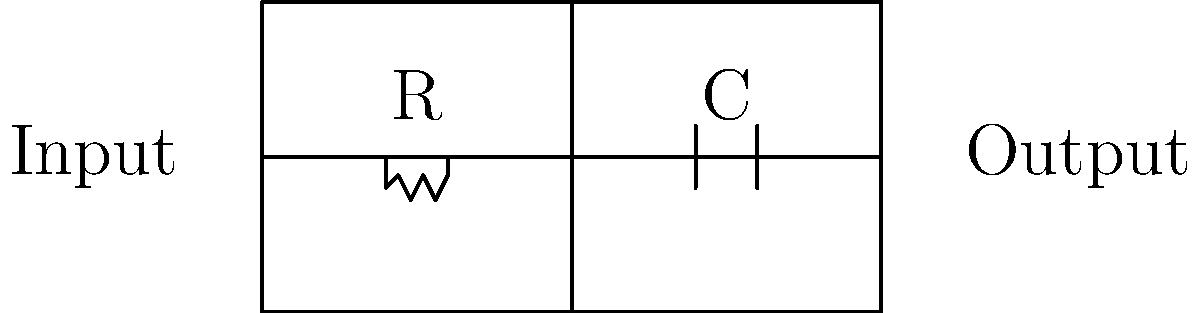In the context of early electronic music synthesizers, particularly those influenced by the Frankfurt School's critique of mass culture, analyze the circuit diagram provided. How might this simple RC (Resistor-Capacitor) filter contribute to the transformation of sound, and what philosophical implications could this have in relation to Adorno's concept of the "culture industry"? To answer this question, we need to consider both the technical aspects of the circuit and its potential philosophical implications:

1. Circuit Analysis:
   - The diagram shows a basic RC low-pass filter.
   - The resistor (R) and capacitor (C) are connected in series.
   - The output is taken across the capacitor.

2. Function in Sound Processing:
   - This filter attenuates high frequencies while allowing low frequencies to pass through.
   - The cutoff frequency is determined by the formula: $f_c = \frac{1}{2\pi RC}$

3. Effect on Sound:
   - It smooths out rapid changes in the input signal.
   - This can result in a "warmer" or "mellower" sound by reducing harsh overtones.

4. Relation to Early Synthesizers:
   - Early synthesizers often used simple analog circuits like this to shape sound.
   - The ability to manipulate sound electronically was revolutionary in music production.

5. Adorno's Concept of the "Culture Industry":
   - Adorno criticized mass-produced culture as standardized and formulaic.
   - He argued that the culture industry dulled critical thinking and individuality.

6. Philosophical Implications:
   - The RC filter, by altering the original signal, could be seen as a form of mediation between the "pure" sound and the listener.
   - This mediation might be interpreted as analogous to how the culture industry mediates between art and the public.
   - However, the ability to manipulate sound could also be seen as a tool for creating new forms of expression, potentially challenging the standardization Adorno critiqued.

7. Dialectical Consideration:
   - The synthesizer, while potentially a tool of the culture industry, also opened up new possibilities for avant-garde and experimental music.
   - This tension between standardization and innovation mirrors Adorno's complex views on the relationship between art and technology.

In conclusion, this simple circuit embodies the dual nature of technology in art: it can both limit and expand creative possibilities, reflecting the broader tensions Adorno identified in modern culture.
Answer: The RC filter mediates sound, embodying the tension between standardization and innovation in electronic music, reflecting Adorno's critique of the culture industry while potentially offering new forms of artistic expression. 